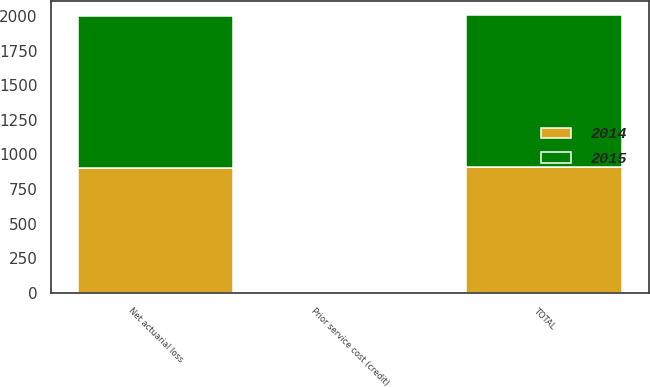Convert chart. <chart><loc_0><loc_0><loc_500><loc_500><stacked_bar_chart><ecel><fcel>Prior service cost (credit)<fcel>Net actuarial loss<fcel>TOTAL<nl><fcel>2015<fcel>3<fcel>1099.9<fcel>1102.9<nl><fcel>2014<fcel>4<fcel>904.7<fcel>908.7<nl></chart> 